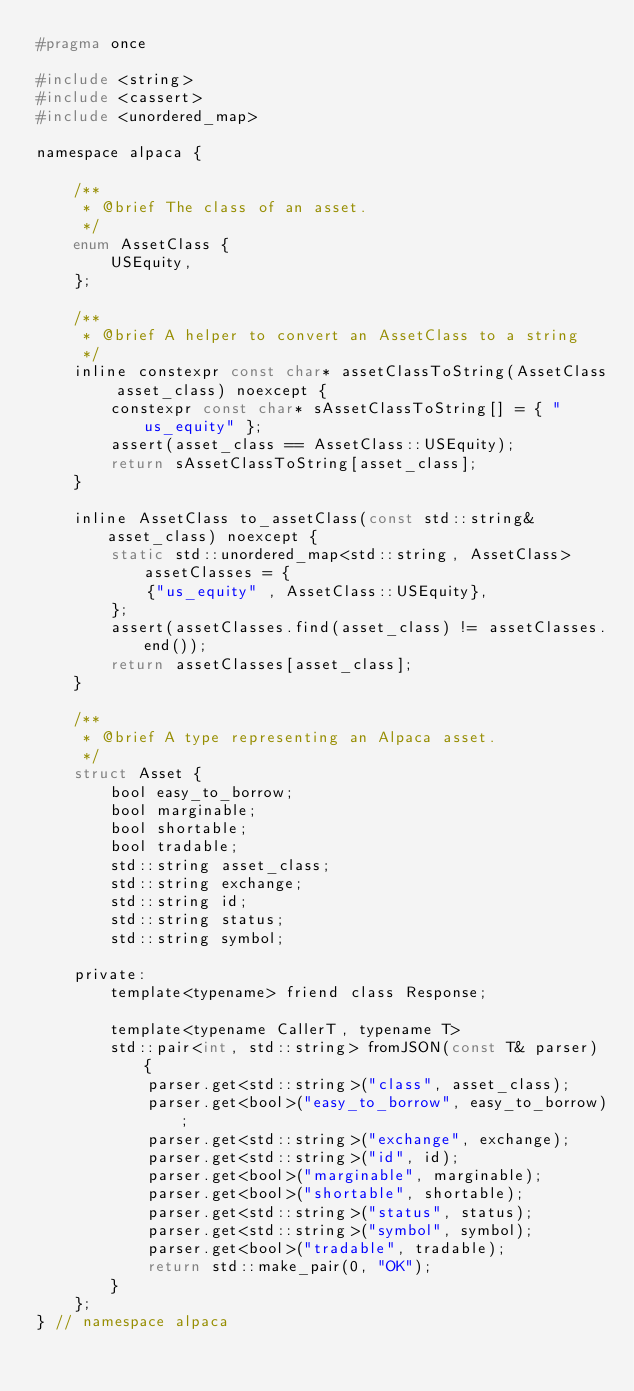Convert code to text. <code><loc_0><loc_0><loc_500><loc_500><_C_>#pragma once

#include <string>
#include <cassert>
#include <unordered_map>

namespace alpaca {

	/**
	 * @brief The class of an asset.
	 */
	enum AssetClass {
		USEquity,
	};

	/**
	 * @brief A helper to convert an AssetClass to a string
	 */
	inline constexpr const char* assetClassToString(AssetClass asset_class) noexcept {
		constexpr const char* sAssetClassToString[] = { "us_equity" };
		assert(asset_class == AssetClass::USEquity);
		return sAssetClassToString[asset_class];
	}

	inline AssetClass to_assetClass(const std::string& asset_class) noexcept {
		static std::unordered_map<std::string, AssetClass> assetClasses = {
			{"us_equity" , AssetClass::USEquity},
		};
		assert(assetClasses.find(asset_class) != assetClasses.end());
		return assetClasses[asset_class];
	}

	/**
	 * @brief A type representing an Alpaca asset.
	 */
	struct Asset {
		bool easy_to_borrow;
		bool marginable;
		bool shortable;
		bool tradable;
		std::string asset_class;
		std::string exchange;
		std::string id;
		std::string status;
		std::string symbol;

	private:
		template<typename> friend class Response;

		template<typename CallerT, typename T>
		std::pair<int, std::string> fromJSON(const T& parser) {
			parser.get<std::string>("class", asset_class);
			parser.get<bool>("easy_to_borrow", easy_to_borrow);
			parser.get<std::string>("exchange", exchange);
			parser.get<std::string>("id", id);
			parser.get<bool>("marginable", marginable);
			parser.get<bool>("shortable", shortable);
			parser.get<std::string>("status", status);
			parser.get<std::string>("symbol", symbol);
			parser.get<bool>("tradable", tradable);
			return std::make_pair(0, "OK");
		}
	};
} // namespace alpaca</code> 